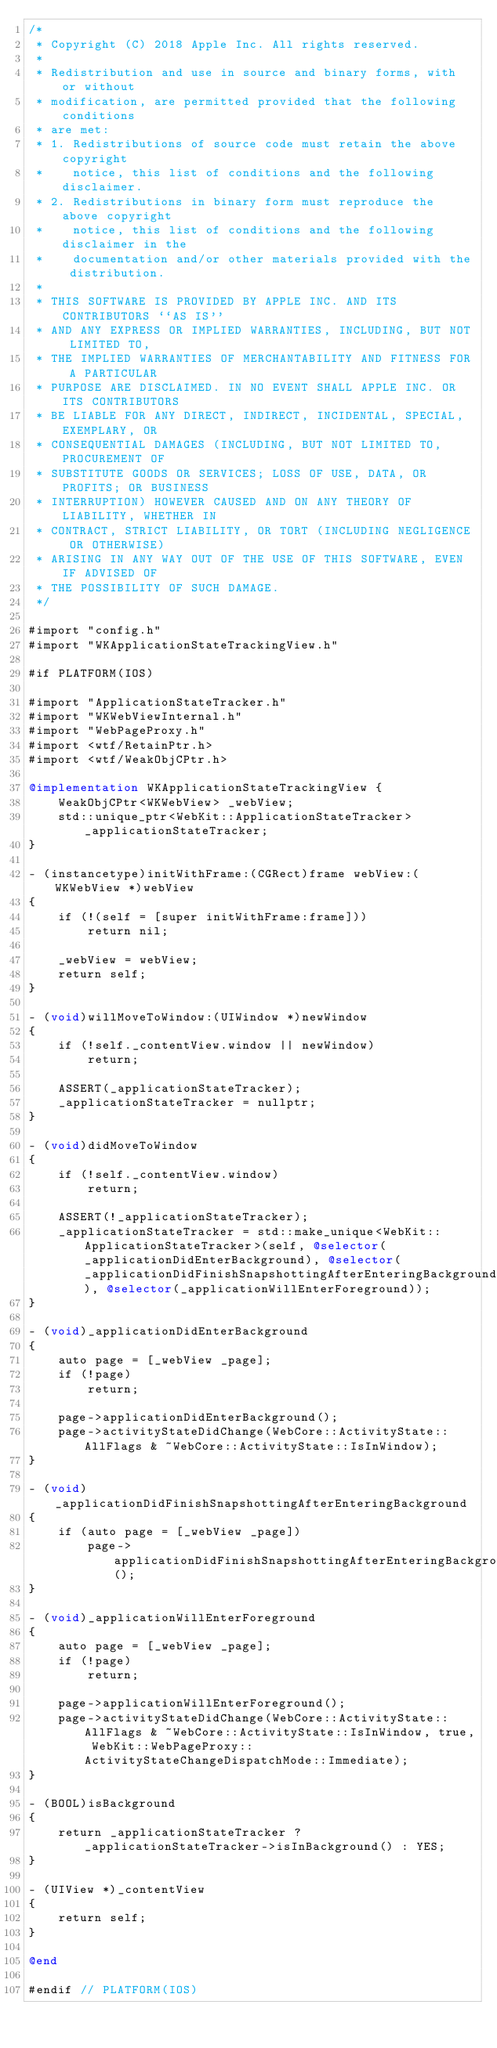<code> <loc_0><loc_0><loc_500><loc_500><_ObjectiveC_>/*
 * Copyright (C) 2018 Apple Inc. All rights reserved.
 *
 * Redistribution and use in source and binary forms, with or without
 * modification, are permitted provided that the following conditions
 * are met:
 * 1. Redistributions of source code must retain the above copyright
 *    notice, this list of conditions and the following disclaimer.
 * 2. Redistributions in binary form must reproduce the above copyright
 *    notice, this list of conditions and the following disclaimer in the
 *    documentation and/or other materials provided with the distribution.
 *
 * THIS SOFTWARE IS PROVIDED BY APPLE INC. AND ITS CONTRIBUTORS ``AS IS''
 * AND ANY EXPRESS OR IMPLIED WARRANTIES, INCLUDING, BUT NOT LIMITED TO,
 * THE IMPLIED WARRANTIES OF MERCHANTABILITY AND FITNESS FOR A PARTICULAR
 * PURPOSE ARE DISCLAIMED. IN NO EVENT SHALL APPLE INC. OR ITS CONTRIBUTORS
 * BE LIABLE FOR ANY DIRECT, INDIRECT, INCIDENTAL, SPECIAL, EXEMPLARY, OR
 * CONSEQUENTIAL DAMAGES (INCLUDING, BUT NOT LIMITED TO, PROCUREMENT OF
 * SUBSTITUTE GOODS OR SERVICES; LOSS OF USE, DATA, OR PROFITS; OR BUSINESS
 * INTERRUPTION) HOWEVER CAUSED AND ON ANY THEORY OF LIABILITY, WHETHER IN
 * CONTRACT, STRICT LIABILITY, OR TORT (INCLUDING NEGLIGENCE OR OTHERWISE)
 * ARISING IN ANY WAY OUT OF THE USE OF THIS SOFTWARE, EVEN IF ADVISED OF
 * THE POSSIBILITY OF SUCH DAMAGE.
 */

#import "config.h"
#import "WKApplicationStateTrackingView.h"

#if PLATFORM(IOS)

#import "ApplicationStateTracker.h"
#import "WKWebViewInternal.h"
#import "WebPageProxy.h"
#import <wtf/RetainPtr.h>
#import <wtf/WeakObjCPtr.h>

@implementation WKApplicationStateTrackingView {
    WeakObjCPtr<WKWebView> _webView;
    std::unique_ptr<WebKit::ApplicationStateTracker> _applicationStateTracker;
}

- (instancetype)initWithFrame:(CGRect)frame webView:(WKWebView *)webView
{
    if (!(self = [super initWithFrame:frame]))
        return nil;

    _webView = webView;
    return self;
}

- (void)willMoveToWindow:(UIWindow *)newWindow
{
    if (!self._contentView.window || newWindow)
        return;

    ASSERT(_applicationStateTracker);
    _applicationStateTracker = nullptr;
}

- (void)didMoveToWindow
{
    if (!self._contentView.window)
        return;

    ASSERT(!_applicationStateTracker);
    _applicationStateTracker = std::make_unique<WebKit::ApplicationStateTracker>(self, @selector(_applicationDidEnterBackground), @selector(_applicationDidFinishSnapshottingAfterEnteringBackground), @selector(_applicationWillEnterForeground));
}

- (void)_applicationDidEnterBackground
{
    auto page = [_webView _page];
    if (!page)
        return;

    page->applicationDidEnterBackground();
    page->activityStateDidChange(WebCore::ActivityState::AllFlags & ~WebCore::ActivityState::IsInWindow);
}

- (void)_applicationDidFinishSnapshottingAfterEnteringBackground
{
    if (auto page = [_webView _page])
        page->applicationDidFinishSnapshottingAfterEnteringBackground();
}

- (void)_applicationWillEnterForeground
{
    auto page = [_webView _page];
    if (!page)
        return;

    page->applicationWillEnterForeground();
    page->activityStateDidChange(WebCore::ActivityState::AllFlags & ~WebCore::ActivityState::IsInWindow, true, WebKit::WebPageProxy::ActivityStateChangeDispatchMode::Immediate);
}

- (BOOL)isBackground
{
    return _applicationStateTracker ? _applicationStateTracker->isInBackground() : YES;
}

- (UIView *)_contentView
{
    return self;
}

@end

#endif // PLATFORM(IOS)
</code> 